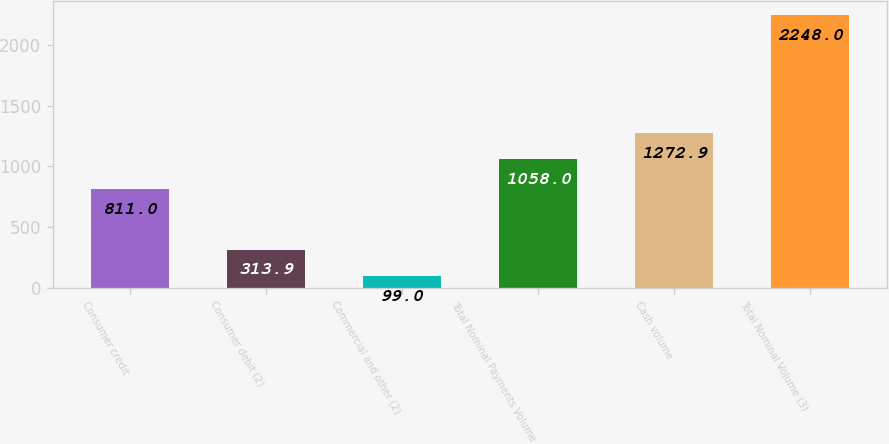Convert chart. <chart><loc_0><loc_0><loc_500><loc_500><bar_chart><fcel>Consumer credit<fcel>Consumer debit (2)<fcel>Commercial and other (2)<fcel>Total Nominal Payments Volume<fcel>Cash volume<fcel>Total Nominal Volume (3)<nl><fcel>811<fcel>313.9<fcel>99<fcel>1058<fcel>1272.9<fcel>2248<nl></chart> 